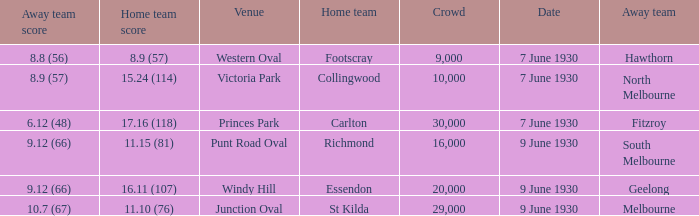What is the average crowd to watch Hawthorn as the away team? 9000.0. 